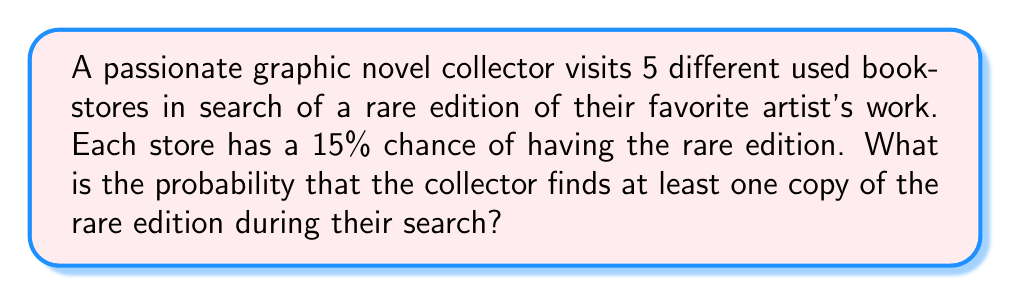Provide a solution to this math problem. To solve this problem, we'll use the complement rule of probability. Instead of calculating the probability of finding at least one copy, we'll calculate the probability of not finding any copies and then subtract that from 1.

Let's break it down step-by-step:

1. Probability of not finding the rare edition in a single store:
   $P(\text{not finding}) = 1 - 0.15 = 0.85$ or 85%

2. Probability of not finding the rare edition in all 5 stores:
   $P(\text{not finding in any store}) = 0.85^5$

3. Probability of finding at least one copy:
   $P(\text{finding at least one}) = 1 - P(\text{not finding in any store})$

   $$ P(\text{finding at least one}) = 1 - 0.85^5 $$

4. Calculate the result:
   $$ \begin{align}
   P(\text{finding at least one}) &= 1 - 0.85^5 \\
   &= 1 - 0.4437 \\
   &= 0.5563
   \end{align} $$

5. Convert to percentage:
   $0.5563 \times 100\% = 55.63\%$

Therefore, the probability of finding at least one copy of the rare edition during the collector's search is approximately 55.63%.
Answer: The probability of finding at least one copy of the rare edition is approximately 55.63%. 